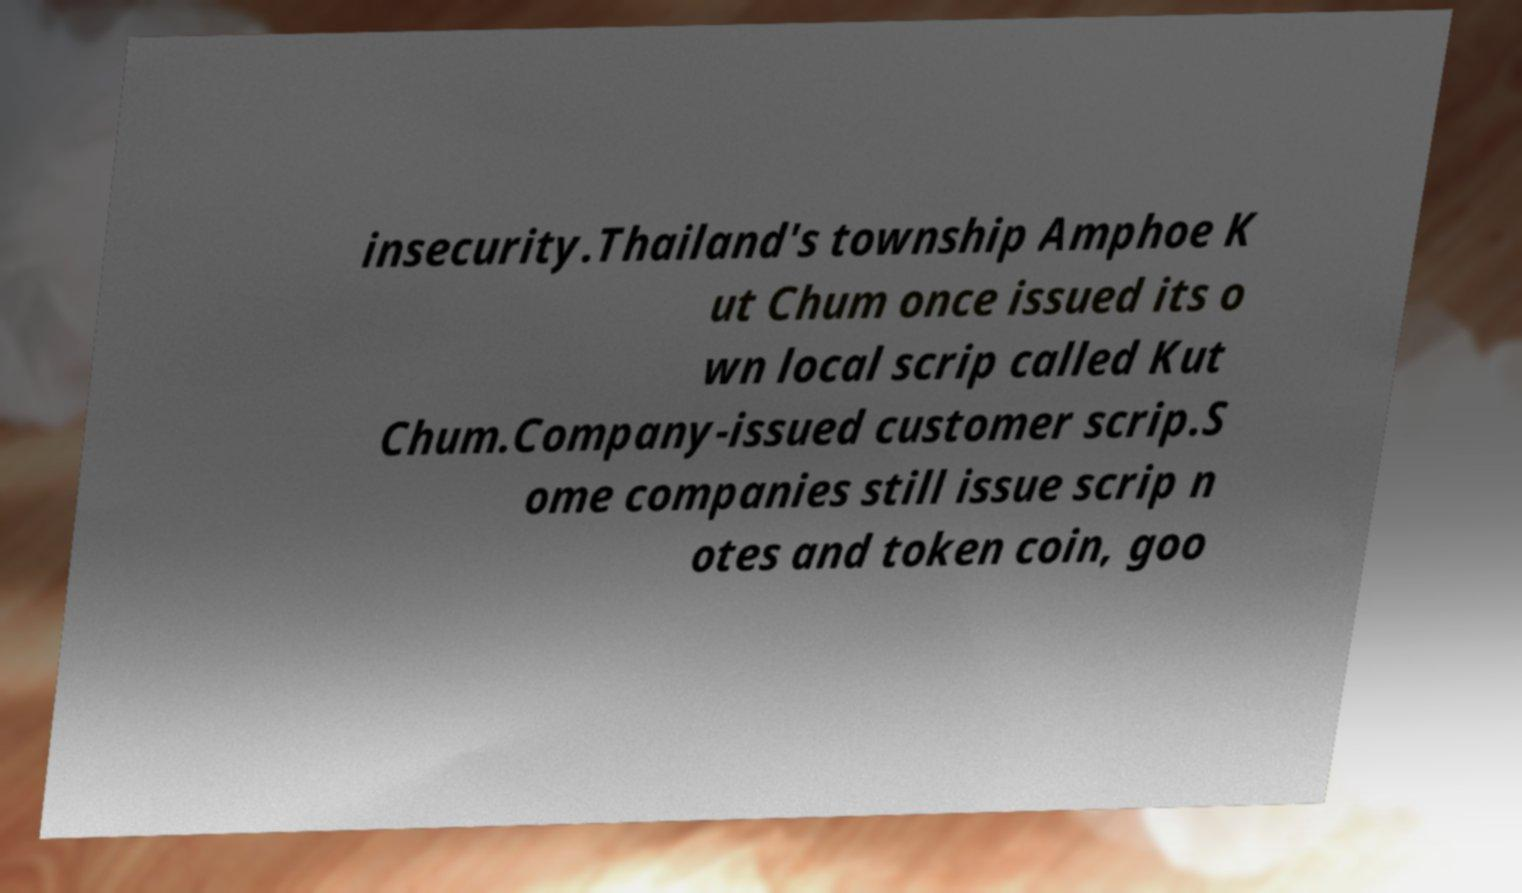Please read and relay the text visible in this image. What does it say? insecurity.Thailand's township Amphoe K ut Chum once issued its o wn local scrip called Kut Chum.Company-issued customer scrip.S ome companies still issue scrip n otes and token coin, goo 